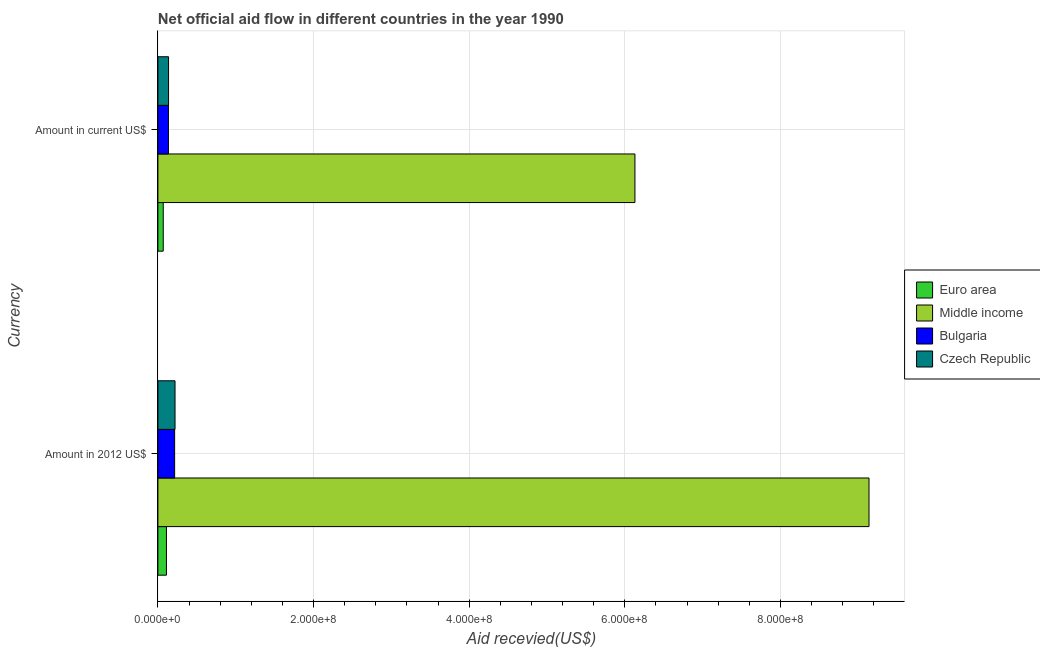How many different coloured bars are there?
Your answer should be very brief. 4. How many groups of bars are there?
Provide a short and direct response. 2. How many bars are there on the 2nd tick from the top?
Ensure brevity in your answer.  4. What is the label of the 1st group of bars from the top?
Provide a short and direct response. Amount in current US$. What is the amount of aid received(expressed in us$) in Czech Republic?
Offer a terse response. 1.37e+07. Across all countries, what is the maximum amount of aid received(expressed in us$)?
Your answer should be compact. 6.13e+08. Across all countries, what is the minimum amount of aid received(expressed in 2012 us$)?
Provide a succinct answer. 1.10e+07. In which country was the amount of aid received(expressed in 2012 us$) maximum?
Provide a short and direct response. Middle income. What is the total amount of aid received(expressed in 2012 us$) in the graph?
Provide a succinct answer. 9.68e+08. What is the difference between the amount of aid received(expressed in us$) in Euro area and that in Middle income?
Your answer should be compact. -6.06e+08. What is the difference between the amount of aid received(expressed in 2012 us$) in Middle income and the amount of aid received(expressed in us$) in Bulgaria?
Keep it short and to the point. 9.00e+08. What is the average amount of aid received(expressed in us$) per country?
Provide a short and direct response. 1.62e+08. What is the difference between the amount of aid received(expressed in 2012 us$) and amount of aid received(expressed in us$) in Euro area?
Make the answer very short. 4.15e+06. What is the ratio of the amount of aid received(expressed in us$) in Czech Republic to that in Middle income?
Your response must be concise. 0.02. What does the 4th bar from the top in Amount in 2012 US$ represents?
Give a very brief answer. Euro area. What does the 4th bar from the bottom in Amount in 2012 US$ represents?
Make the answer very short. Czech Republic. Are all the bars in the graph horizontal?
Provide a succinct answer. Yes. How many countries are there in the graph?
Provide a succinct answer. 4. Does the graph contain any zero values?
Ensure brevity in your answer.  No. Does the graph contain grids?
Offer a terse response. Yes. How many legend labels are there?
Ensure brevity in your answer.  4. What is the title of the graph?
Make the answer very short. Net official aid flow in different countries in the year 1990. What is the label or title of the X-axis?
Provide a succinct answer. Aid recevied(US$). What is the label or title of the Y-axis?
Your answer should be very brief. Currency. What is the Aid recevied(US$) of Euro area in Amount in 2012 US$?
Offer a very short reply. 1.10e+07. What is the Aid recevied(US$) of Middle income in Amount in 2012 US$?
Provide a succinct answer. 9.14e+08. What is the Aid recevied(US$) of Bulgaria in Amount in 2012 US$?
Make the answer very short. 2.15e+07. What is the Aid recevied(US$) of Czech Republic in Amount in 2012 US$?
Make the answer very short. 2.20e+07. What is the Aid recevied(US$) in Euro area in Amount in current US$?
Provide a short and direct response. 6.84e+06. What is the Aid recevied(US$) of Middle income in Amount in current US$?
Your answer should be very brief. 6.13e+08. What is the Aid recevied(US$) in Bulgaria in Amount in current US$?
Ensure brevity in your answer.  1.36e+07. What is the Aid recevied(US$) in Czech Republic in Amount in current US$?
Your answer should be very brief. 1.37e+07. Across all Currency, what is the maximum Aid recevied(US$) in Euro area?
Ensure brevity in your answer.  1.10e+07. Across all Currency, what is the maximum Aid recevied(US$) in Middle income?
Keep it short and to the point. 9.14e+08. Across all Currency, what is the maximum Aid recevied(US$) in Bulgaria?
Offer a very short reply. 2.15e+07. Across all Currency, what is the maximum Aid recevied(US$) in Czech Republic?
Offer a very short reply. 2.20e+07. Across all Currency, what is the minimum Aid recevied(US$) in Euro area?
Give a very brief answer. 6.84e+06. Across all Currency, what is the minimum Aid recevied(US$) in Middle income?
Ensure brevity in your answer.  6.13e+08. Across all Currency, what is the minimum Aid recevied(US$) in Bulgaria?
Provide a short and direct response. 1.36e+07. Across all Currency, what is the minimum Aid recevied(US$) in Czech Republic?
Your response must be concise. 1.37e+07. What is the total Aid recevied(US$) in Euro area in the graph?
Ensure brevity in your answer.  1.78e+07. What is the total Aid recevied(US$) in Middle income in the graph?
Provide a short and direct response. 1.53e+09. What is the total Aid recevied(US$) of Bulgaria in the graph?
Give a very brief answer. 3.51e+07. What is the total Aid recevied(US$) in Czech Republic in the graph?
Your answer should be very brief. 3.57e+07. What is the difference between the Aid recevied(US$) in Euro area in Amount in 2012 US$ and that in Amount in current US$?
Offer a terse response. 4.15e+06. What is the difference between the Aid recevied(US$) of Middle income in Amount in 2012 US$ and that in Amount in current US$?
Your answer should be very brief. 3.01e+08. What is the difference between the Aid recevied(US$) in Bulgaria in Amount in 2012 US$ and that in Amount in current US$?
Make the answer very short. 7.87e+06. What is the difference between the Aid recevied(US$) in Czech Republic in Amount in 2012 US$ and that in Amount in current US$?
Offer a very short reply. 8.33e+06. What is the difference between the Aid recevied(US$) of Euro area in Amount in 2012 US$ and the Aid recevied(US$) of Middle income in Amount in current US$?
Keep it short and to the point. -6.02e+08. What is the difference between the Aid recevied(US$) of Euro area in Amount in 2012 US$ and the Aid recevied(US$) of Bulgaria in Amount in current US$?
Make the answer very short. -2.63e+06. What is the difference between the Aid recevied(US$) of Euro area in Amount in 2012 US$ and the Aid recevied(US$) of Czech Republic in Amount in current US$?
Provide a short and direct response. -2.69e+06. What is the difference between the Aid recevied(US$) in Middle income in Amount in 2012 US$ and the Aid recevied(US$) in Bulgaria in Amount in current US$?
Make the answer very short. 9.00e+08. What is the difference between the Aid recevied(US$) in Middle income in Amount in 2012 US$ and the Aid recevied(US$) in Czech Republic in Amount in current US$?
Your answer should be compact. 9.00e+08. What is the difference between the Aid recevied(US$) in Bulgaria in Amount in 2012 US$ and the Aid recevied(US$) in Czech Republic in Amount in current US$?
Your response must be concise. 7.81e+06. What is the average Aid recevied(US$) of Euro area per Currency?
Your answer should be very brief. 8.92e+06. What is the average Aid recevied(US$) of Middle income per Currency?
Provide a succinct answer. 7.63e+08. What is the average Aid recevied(US$) in Bulgaria per Currency?
Ensure brevity in your answer.  1.76e+07. What is the average Aid recevied(US$) in Czech Republic per Currency?
Your response must be concise. 1.78e+07. What is the difference between the Aid recevied(US$) in Euro area and Aid recevied(US$) in Middle income in Amount in 2012 US$?
Give a very brief answer. -9.03e+08. What is the difference between the Aid recevied(US$) in Euro area and Aid recevied(US$) in Bulgaria in Amount in 2012 US$?
Your response must be concise. -1.05e+07. What is the difference between the Aid recevied(US$) in Euro area and Aid recevied(US$) in Czech Republic in Amount in 2012 US$?
Provide a succinct answer. -1.10e+07. What is the difference between the Aid recevied(US$) of Middle income and Aid recevied(US$) of Bulgaria in Amount in 2012 US$?
Keep it short and to the point. 8.92e+08. What is the difference between the Aid recevied(US$) of Middle income and Aid recevied(US$) of Czech Republic in Amount in 2012 US$?
Offer a very short reply. 8.92e+08. What is the difference between the Aid recevied(US$) of Bulgaria and Aid recevied(US$) of Czech Republic in Amount in 2012 US$?
Ensure brevity in your answer.  -5.20e+05. What is the difference between the Aid recevied(US$) of Euro area and Aid recevied(US$) of Middle income in Amount in current US$?
Your answer should be very brief. -6.06e+08. What is the difference between the Aid recevied(US$) in Euro area and Aid recevied(US$) in Bulgaria in Amount in current US$?
Give a very brief answer. -6.78e+06. What is the difference between the Aid recevied(US$) in Euro area and Aid recevied(US$) in Czech Republic in Amount in current US$?
Provide a short and direct response. -6.84e+06. What is the difference between the Aid recevied(US$) of Middle income and Aid recevied(US$) of Bulgaria in Amount in current US$?
Keep it short and to the point. 5.99e+08. What is the difference between the Aid recevied(US$) in Middle income and Aid recevied(US$) in Czech Republic in Amount in current US$?
Provide a succinct answer. 5.99e+08. What is the ratio of the Aid recevied(US$) in Euro area in Amount in 2012 US$ to that in Amount in current US$?
Your answer should be very brief. 1.61. What is the ratio of the Aid recevied(US$) in Middle income in Amount in 2012 US$ to that in Amount in current US$?
Offer a very short reply. 1.49. What is the ratio of the Aid recevied(US$) in Bulgaria in Amount in 2012 US$ to that in Amount in current US$?
Give a very brief answer. 1.58. What is the ratio of the Aid recevied(US$) of Czech Republic in Amount in 2012 US$ to that in Amount in current US$?
Your answer should be compact. 1.61. What is the difference between the highest and the second highest Aid recevied(US$) in Euro area?
Offer a terse response. 4.15e+06. What is the difference between the highest and the second highest Aid recevied(US$) of Middle income?
Make the answer very short. 3.01e+08. What is the difference between the highest and the second highest Aid recevied(US$) in Bulgaria?
Your response must be concise. 7.87e+06. What is the difference between the highest and the second highest Aid recevied(US$) in Czech Republic?
Provide a succinct answer. 8.33e+06. What is the difference between the highest and the lowest Aid recevied(US$) in Euro area?
Offer a very short reply. 4.15e+06. What is the difference between the highest and the lowest Aid recevied(US$) of Middle income?
Your answer should be very brief. 3.01e+08. What is the difference between the highest and the lowest Aid recevied(US$) in Bulgaria?
Offer a terse response. 7.87e+06. What is the difference between the highest and the lowest Aid recevied(US$) of Czech Republic?
Your response must be concise. 8.33e+06. 